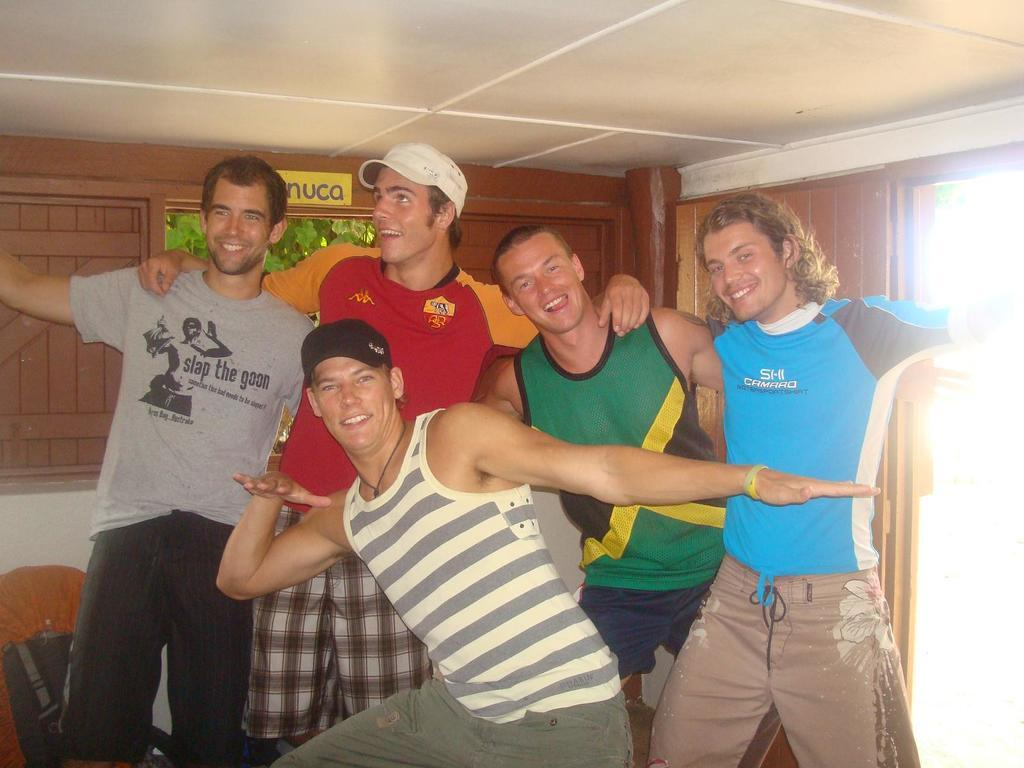Who is present in the image? There are men in the image. What expressions do the men have on their faces? The men have smiles on their faces. What type of headwear are two of the men wearing? Two of the men are wearing caps. What can be seen behind the men in the image? There is text or an image visible behind the men. What type of pipe can be seen in the image? There is no pipe present in the image. Is there a dog visible in the image? No, there is no dog present in the image. 